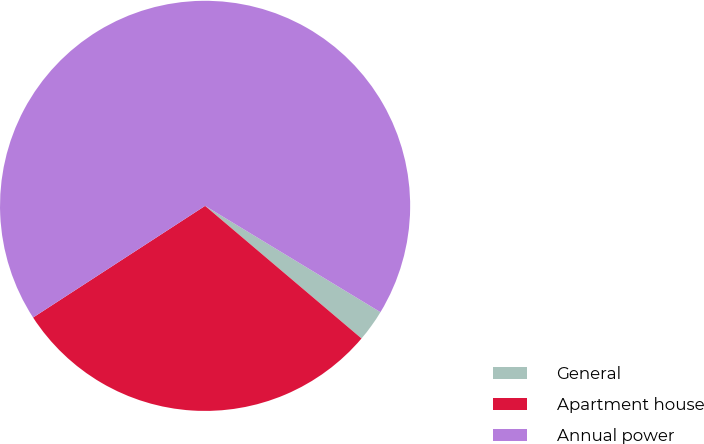Convert chart to OTSL. <chart><loc_0><loc_0><loc_500><loc_500><pie_chart><fcel>General<fcel>Apartment house<fcel>Annual power<nl><fcel>2.52%<fcel>29.64%<fcel>67.83%<nl></chart> 